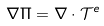<formula> <loc_0><loc_0><loc_500><loc_500>\nabla \Pi = \nabla \cdot { \mathcal { T } } ^ { e }</formula> 